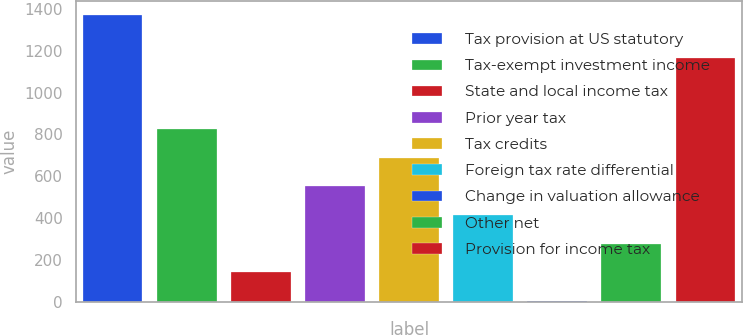<chart> <loc_0><loc_0><loc_500><loc_500><bar_chart><fcel>Tax provision at US statutory<fcel>Tax-exempt investment income<fcel>State and local income tax<fcel>Prior year tax<fcel>Tax credits<fcel>Foreign tax rate differential<fcel>Change in valuation allowance<fcel>Other net<fcel>Provision for income tax<nl><fcel>1369<fcel>824.2<fcel>143.2<fcel>551.8<fcel>688<fcel>415.6<fcel>7<fcel>279.4<fcel>1165<nl></chart> 